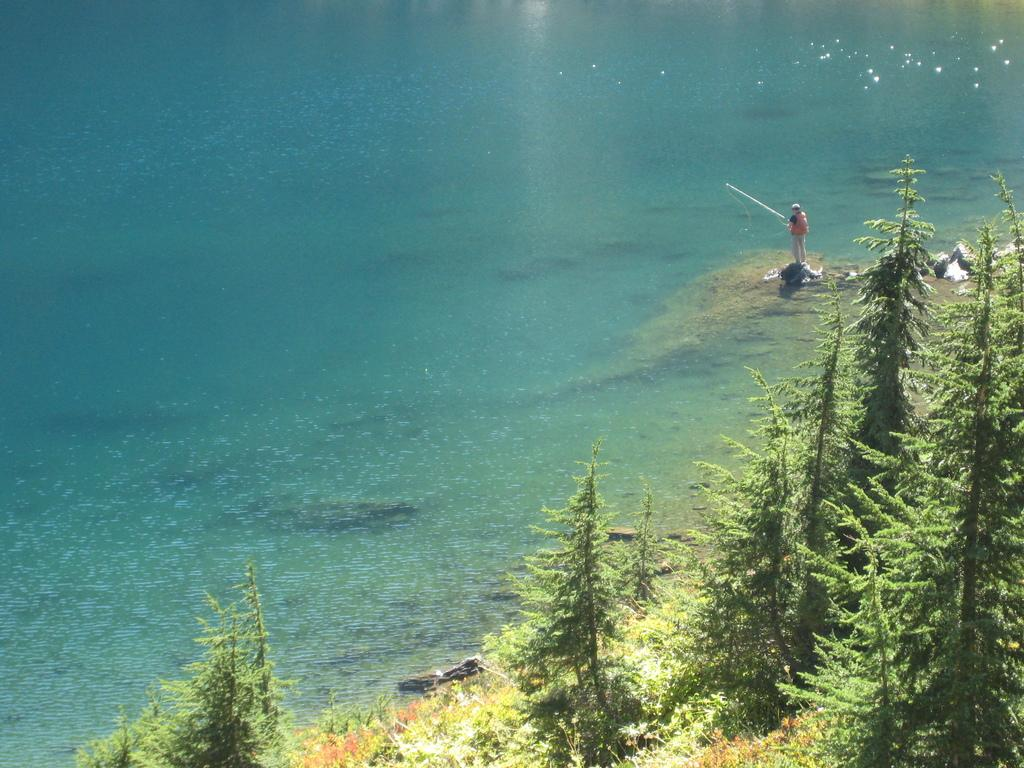What type of vegetation is in the foreground of the image? There are trees in the foreground of the image. Where are the trees located in relation to the ocean? The trees are located near the ocean. What is the man in the image doing? The man is holding a fishing device. What can be seen in the background of the image? There is water visible in the image. What type of bulb is the man using to help him catch the clams in the image? There is no bulb or clams present in the image. The man is holding a fishing device, not a device for catching clams. 